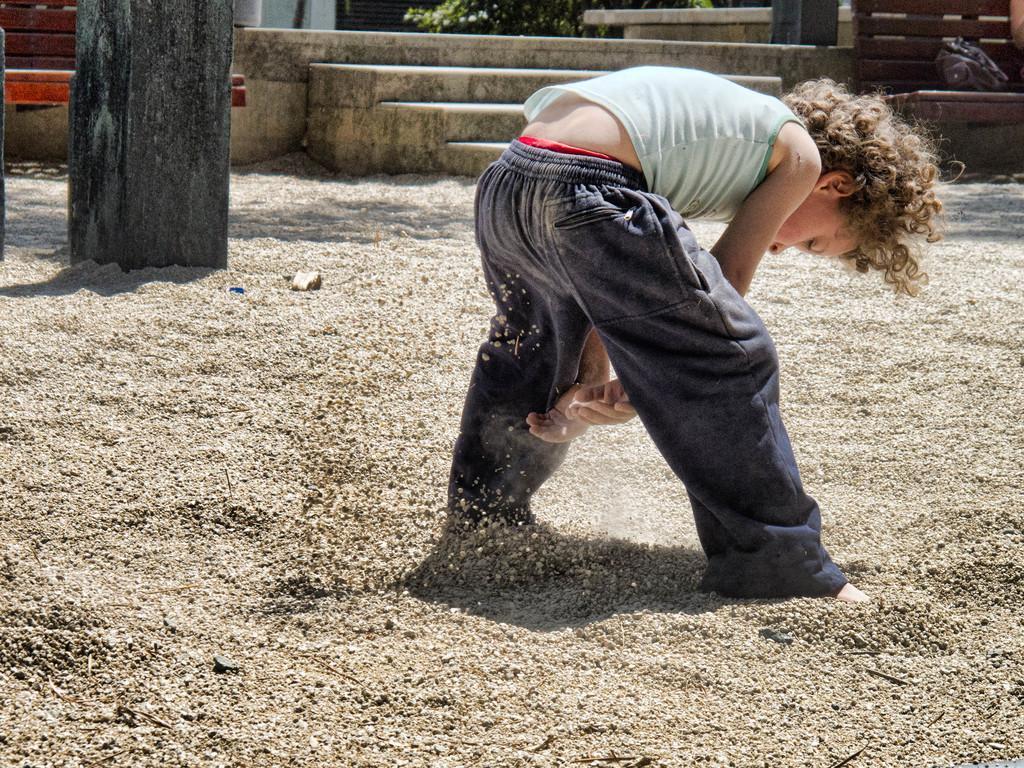How would you summarize this image in a sentence or two? In this image there is a boy visible in the foreground, at the top there are benches, steps, on the bench may be there is a bag kept on it, visible in the top right, a branch of plant visible, there is a pillar visible in the top left. 